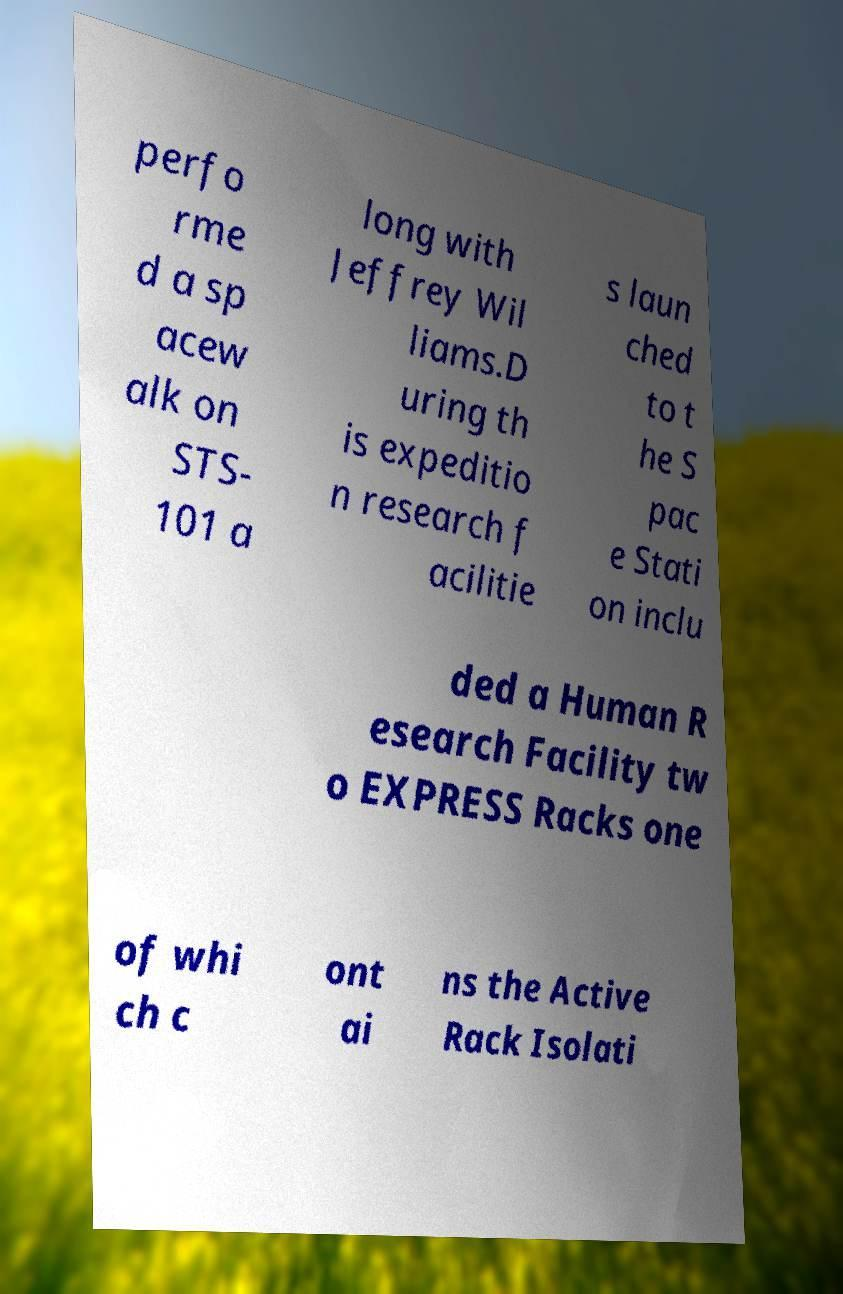What messages or text are displayed in this image? I need them in a readable, typed format. perfo rme d a sp acew alk on STS- 101 a long with Jeffrey Wil liams.D uring th is expeditio n research f acilitie s laun ched to t he S pac e Stati on inclu ded a Human R esearch Facility tw o EXPRESS Racks one of whi ch c ont ai ns the Active Rack Isolati 